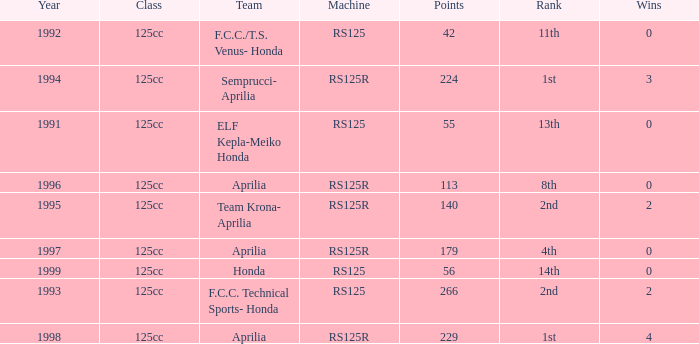Which class had a machine of RS125R, points over 113, and a rank of 4th? 125cc. 